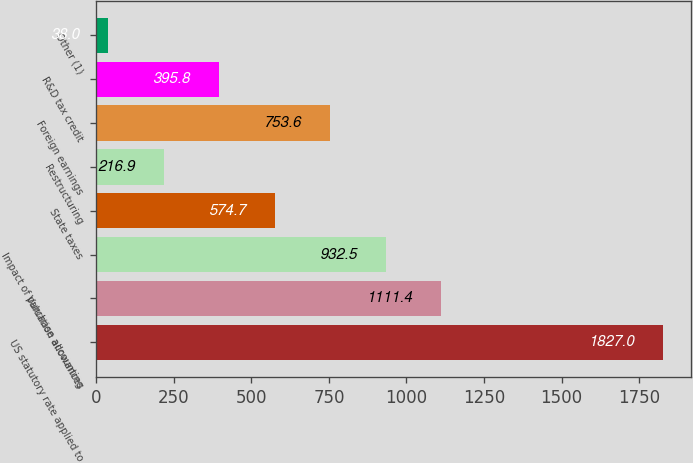Convert chart to OTSL. <chart><loc_0><loc_0><loc_500><loc_500><bar_chart><fcel>US statutory rate applied to<fcel>Valuation allowances<fcel>Impact of purchase accounting<fcel>State taxes<fcel>Restructuring<fcel>Foreign earnings<fcel>R&D tax credit<fcel>Other (1)<nl><fcel>1827<fcel>1111.4<fcel>932.5<fcel>574.7<fcel>216.9<fcel>753.6<fcel>395.8<fcel>38<nl></chart> 